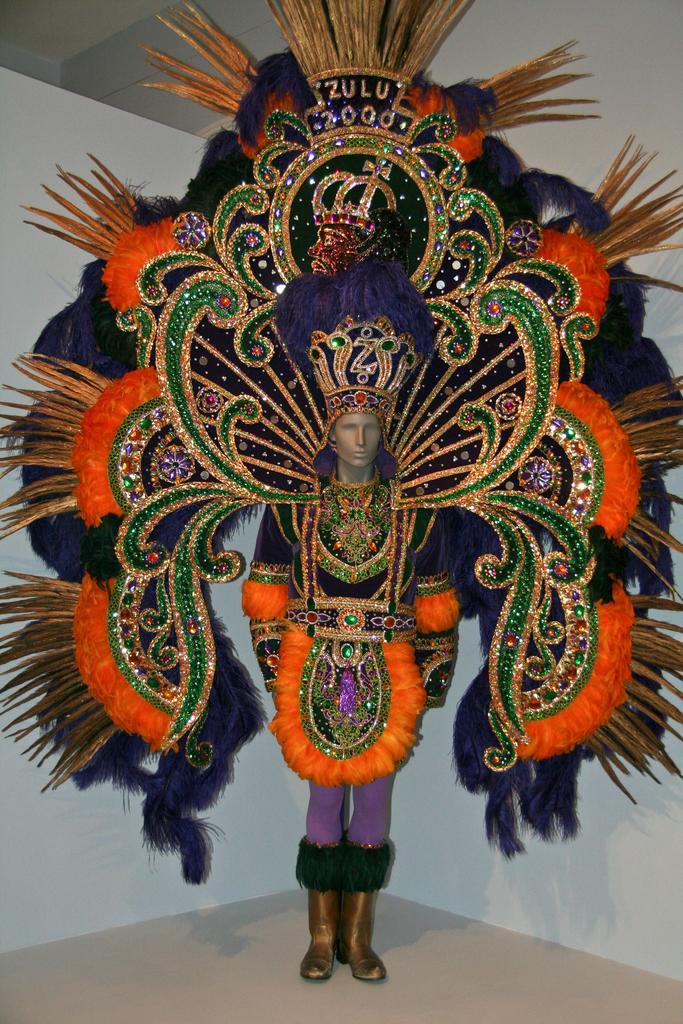Describe this image in one or two sentences. In the foreground of this image, there is a mannequin with a carnival dress. Behind it, there is white wall. 